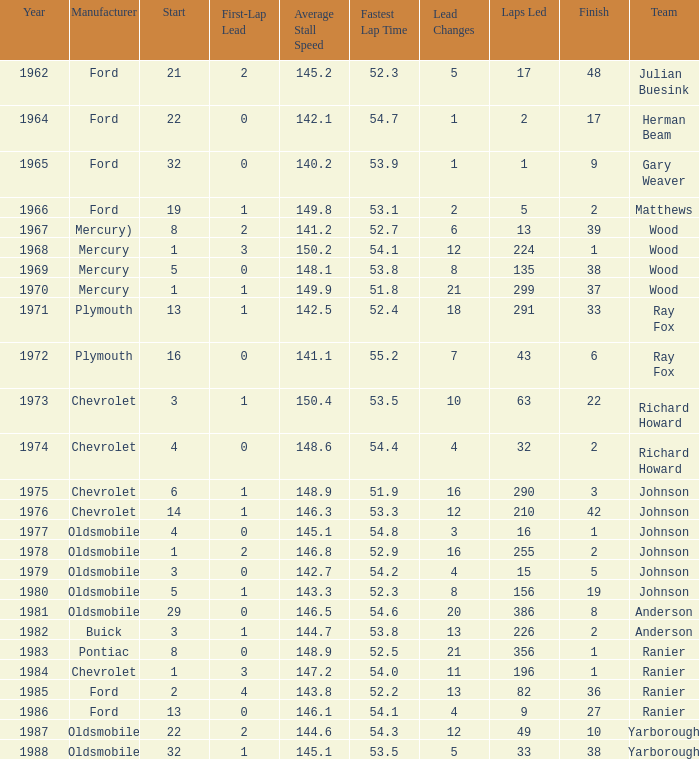What is the smallest finish time for a race where start was less than 3, buick was the manufacturer, and the race was held after 1978? None. Would you be able to parse every entry in this table? {'header': ['Year', 'Manufacturer', 'Start', 'First-Lap Lead', 'Average Stall Speed', 'Fastest Lap Time', 'Lead Changes', 'Laps Led', 'Finish', 'Team'], 'rows': [['1962', 'Ford', '21', '2', '145.2', '52.3', '5', '17', '48', 'Julian Buesink'], ['1964', 'Ford', '22', '0', '142.1', '54.7', '1', '2', '17', 'Herman Beam'], ['1965', 'Ford', '32', '0', '140.2', '53.9', '1', '1', '9', 'Gary Weaver'], ['1966', 'Ford', '19', '1', '149.8', '53.1', '2', '5', '2', 'Matthews'], ['1967', 'Mercury)', '8', '2', '141.2', '52.7', '6', '13', '39', 'Wood'], ['1968', 'Mercury', '1', '3', '150.2', '54.1', '12', '224', '1', 'Wood'], ['1969', 'Mercury', '5', '0', '148.1', '53.8', '8', '135', '38', 'Wood'], ['1970', 'Mercury', '1', '1', '149.9', '51.8', '21', '299', '37', 'Wood'], ['1971', 'Plymouth', '13', '1', '142.5', '52.4', '18', '291', '33', 'Ray Fox'], ['1972', 'Plymouth', '16', '0', '141.1', '55.2', '7', '43', '6', 'Ray Fox'], ['1973', 'Chevrolet', '3', '1', '150.4', '53.5', '10', '63', '22', 'Richard Howard'], ['1974', 'Chevrolet', '4', '0', '148.6', '54.4', '4', '32', '2', 'Richard Howard'], ['1975', 'Chevrolet', '6', '1', '148.9', '51.9', '16', '290', '3', 'Johnson'], ['1976', 'Chevrolet', '14', '1', '146.3', '53.3', '12', '210', '42', 'Johnson'], ['1977', 'Oldsmobile', '4', '0', '145.1', '54.8', '3', '16', '1', 'Johnson'], ['1978', 'Oldsmobile', '1', '2', '146.8', '52.9', '16', '255', '2', 'Johnson'], ['1979', 'Oldsmobile', '3', '0', '142.7', '54.2', '4', '15', '5', 'Johnson'], ['1980', 'Oldsmobile', '5', '1', '143.3', '52.3', '8', '156', '19', 'Johnson'], ['1981', 'Oldsmobile', '29', '0', '146.5', '54.6', '20', '386', '8', 'Anderson'], ['1982', 'Buick', '3', '1', '144.7', '53.8', '13', '226', '2', 'Anderson'], ['1983', 'Pontiac', '8', '0', '148.9', '52.5', '21', '356', '1', 'Ranier'], ['1984', 'Chevrolet', '1', '3', '147.2', '54.0', '11', '196', '1', 'Ranier'], ['1985', 'Ford', '2', '4', '143.8', '52.2', '13', '82', '36', 'Ranier'], ['1986', 'Ford', '13', '0', '146.1', '54.1', '4', '9', '27', 'Ranier'], ['1987', 'Oldsmobile', '22', '2', '144.6', '54.3', '12', '49', '10', 'Yarborough'], ['1988', 'Oldsmobile', '32', '1', '145.1', '53.5', '5', '33', '38', 'Yarborough']]} 